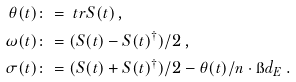<formula> <loc_0><loc_0><loc_500><loc_500>\theta ( t ) & \colon = \ t r S ( t ) \, , \\ \omega ( t ) & \colon = ( S ( t ) - S ( t ) ^ { \dagger } ) / 2 \, , \\ \sigma ( t ) & \colon = ( S ( t ) + S ( t ) ^ { \dagger } ) / 2 - \theta ( t ) / n \cdot \i d _ { E } \, .</formula> 